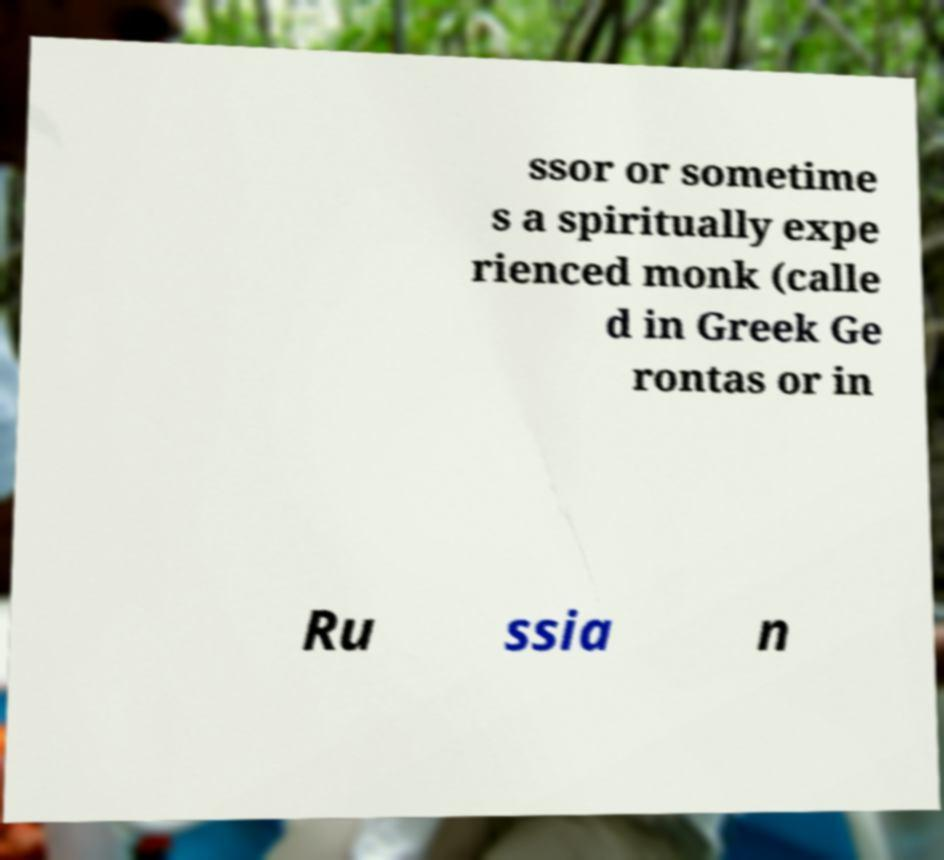Can you accurately transcribe the text from the provided image for me? ssor or sometime s a spiritually expe rienced monk (calle d in Greek Ge rontas or in Ru ssia n 